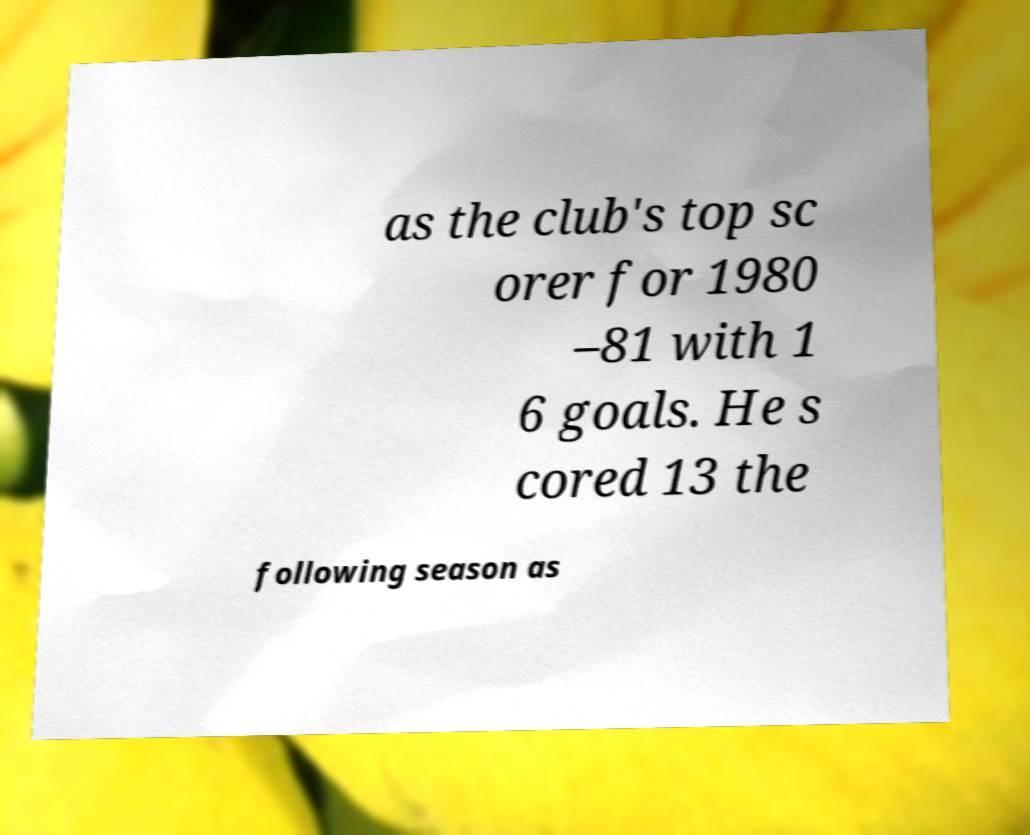I need the written content from this picture converted into text. Can you do that? as the club's top sc orer for 1980 –81 with 1 6 goals. He s cored 13 the following season as 